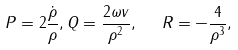Convert formula to latex. <formula><loc_0><loc_0><loc_500><loc_500>P = 2 \frac { \dot { \rho } } { \rho } , Q = \frac { 2 \omega v } { \rho ^ { 2 } } , \text {\ \ } R = - \frac { 4 } { \rho ^ { 3 } } ,</formula> 